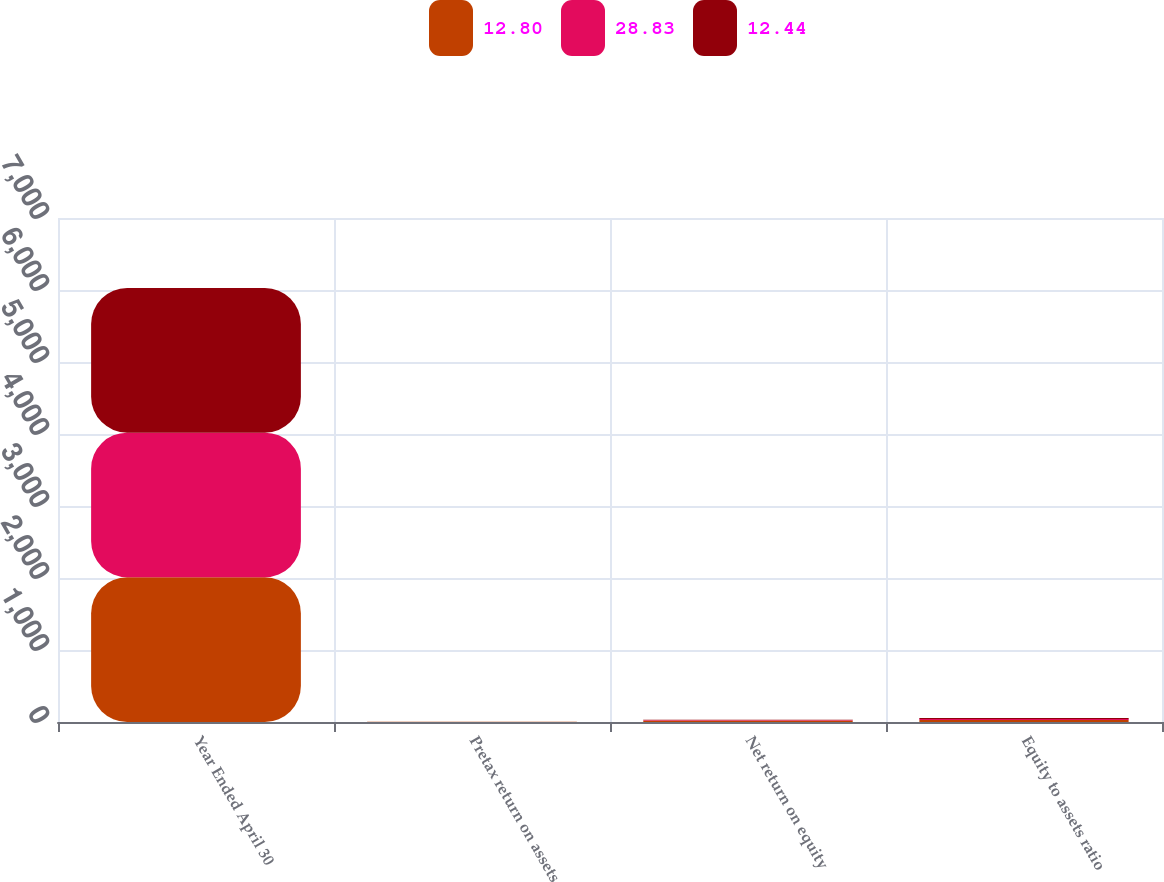Convert chart to OTSL. <chart><loc_0><loc_0><loc_500><loc_500><stacked_bar_chart><ecel><fcel>Year Ended April 30<fcel>Pretax return on assets<fcel>Net return on equity<fcel>Equity to assets ratio<nl><fcel>12.8<fcel>2010<fcel>2.12<fcel>21.04<fcel>28.83<nl><fcel>28.83<fcel>2009<fcel>1.03<fcel>6.67<fcel>12.44<nl><fcel>12.44<fcel>2008<fcel>0.8<fcel>3.32<fcel>12.8<nl></chart> 